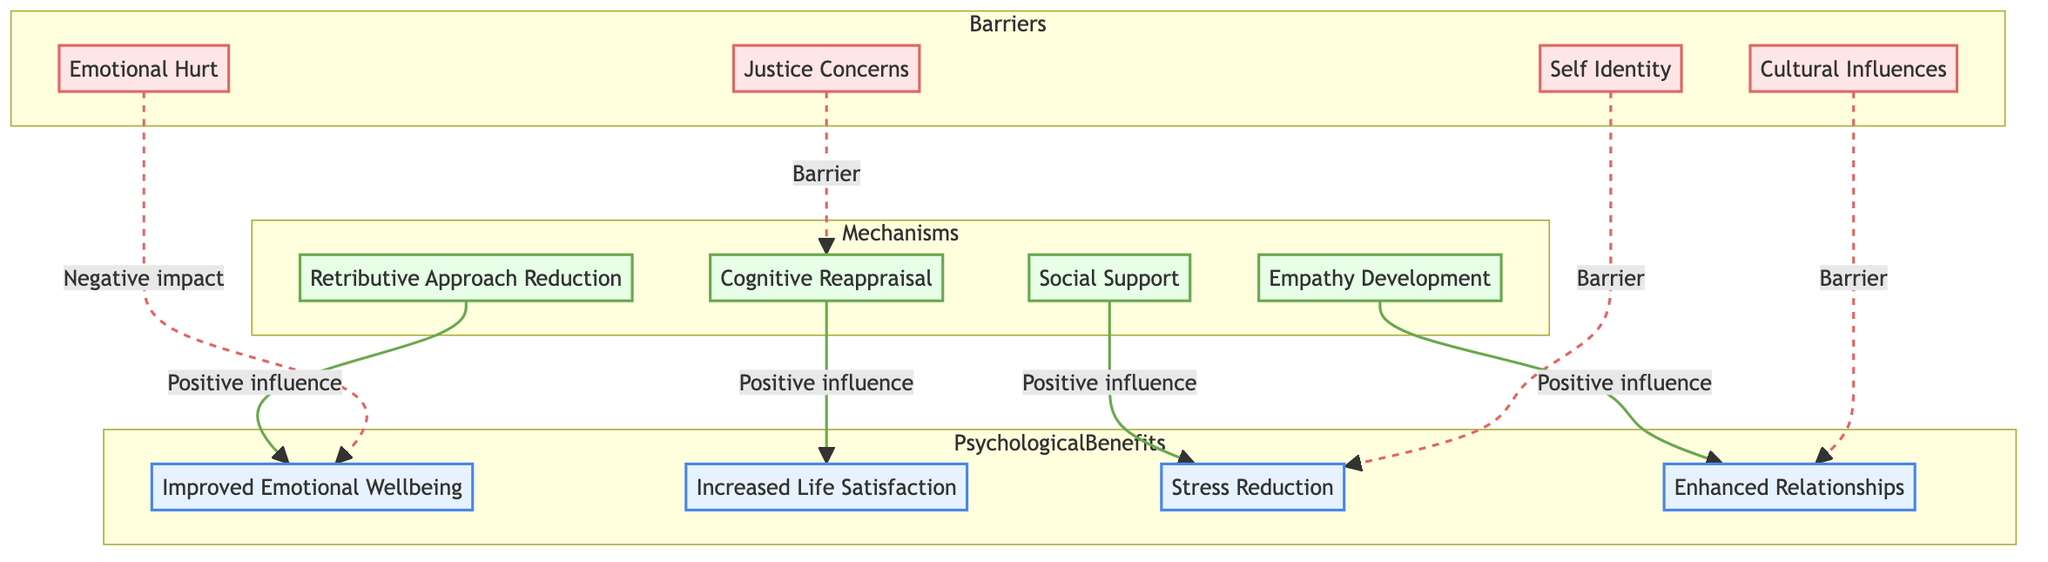What is one psychological benefit of forgiveness? Looking at the block "Psychological Benefits," one of the elements listed is "Improved Emotional Wellbeing," which indicates a benefit of forgiveness.
Answer: Improved Emotional Wellbeing How many barriers are identified in the diagram? The block "Barriers" contains four elements: Emotional Hurt, Justice Concerns, Cultural Influences, and Self Identity. Therefore, there are four identified barriers.
Answer: 4 What does "Justice Concerns" interfere with? The diagram shows a connection from "Justice Concerns" pointing to "Cognitive Reappraisal," labeled as a barrier that indicates it interferes with changing thought patterns.
Answer: Cognitive Reappraisal Which mechanism leads to better relationships? The block "Empathy Development" has a positive influence leading to "Enhanced Relationships," showing that it is the mechanism that fosters better interpersonal connections.
Answer: Enhanced Relationships What is the connection between "Cultural Influences" and "Enhanced Relationships"? The connection shows that "Cultural Influences" serves as a barrier that negatively affects "Enhanced Relationships," suggesting it is an obstacle to improving interpersonal connections.
Answer: Barrier How does "Social Support" impact stress reduction? The relationship displays that "Social Support" has a positive influence on "Stress Reduction," indicating that support systems help in alleviating stress.
Answer: Positive influence Which benefit is improved by "Cognitive Reappraisal"? The arrow showing influence indicates that "Cognitive Reappraisal" positively influences "Increased Life Satisfaction," meaning that it enhances this psychological benefit.
Answer: Increased Life Satisfaction In terms of emotional wellbeing, what role does "Retributive Approach Reduction" play? The diagram illustrates that "Retributive Approach Reduction" has a positive influence on "Improved Emotional Wellbeing," signifying its role in enhancing emotional state.
Answer: Positive influence What is the relationship between "Self Identity" and "Stress Reduction"? The diagram displays "Self Identity" as a barrier that negatively impacts "Stress Reduction," indicating that clinging to a victim identity can exacerbate stress levels.
Answer: Barrier 